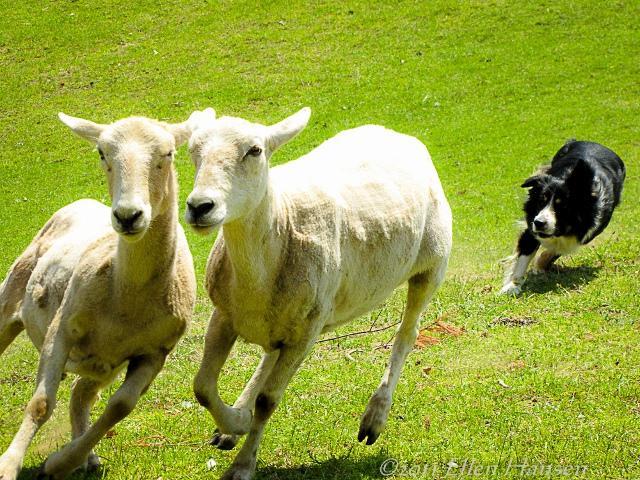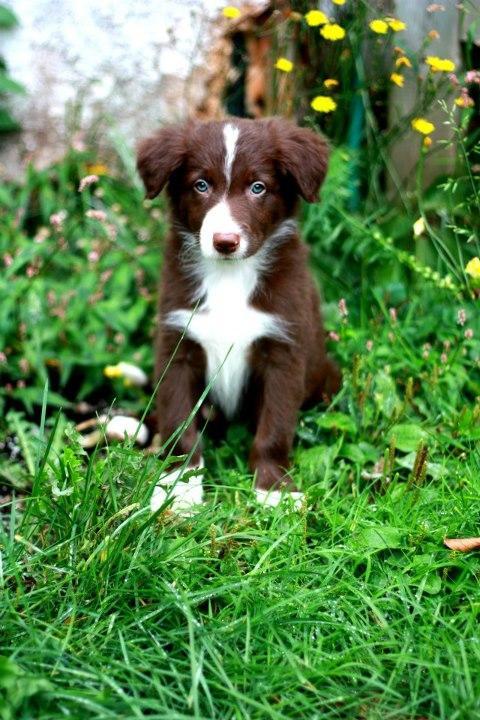The first image is the image on the left, the second image is the image on the right. For the images displayed, is the sentence "The image on the left shows an Australian sheepdog herding 2 or 3 sheep or goats, and the one on the right shows an Australian sheepdog puppy on its own." factually correct? Answer yes or no. Yes. The first image is the image on the left, the second image is the image on the right. For the images shown, is this caption "One image shows a black-and-white dog herding livestock, and the other shows one puppy in bright green grass near wildflowers." true? Answer yes or no. Yes. 